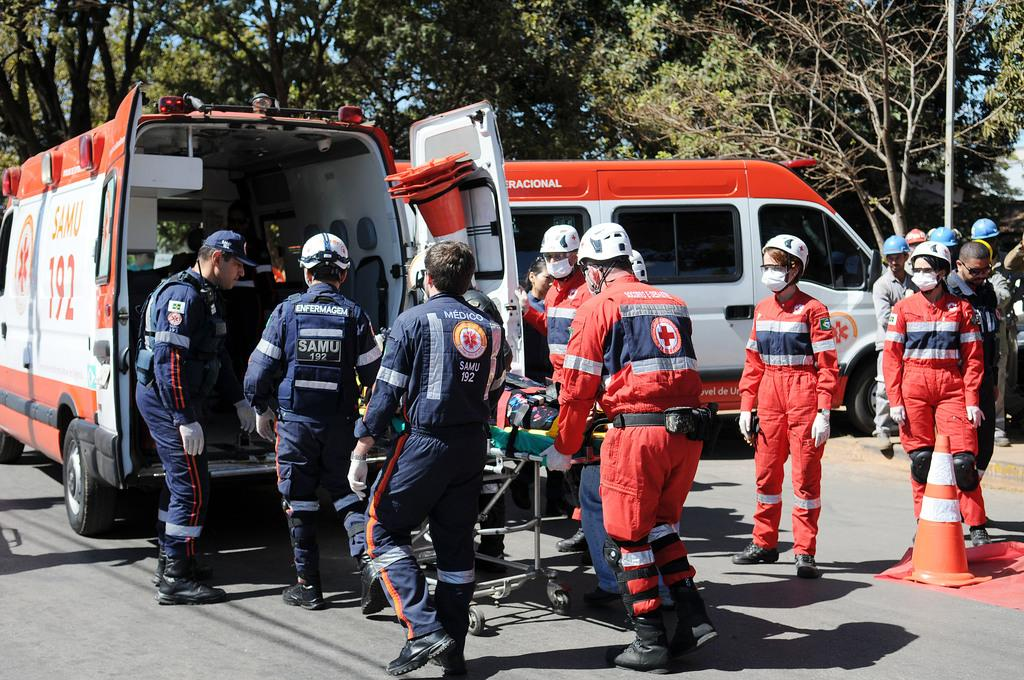Who or what can be seen in the image? There are people in the image. What else is present in the image besides people? There are vehicles, a stretcher, and a traffic cone visible in the image. What can be seen in the background of the image? There are trees in the background of the image. What type of pies are being served on the plate in the image? There is no plate or pies present in the image. 